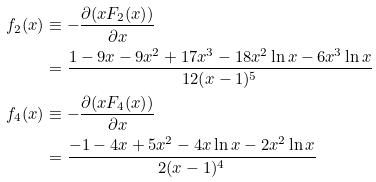Convert formula to latex. <formula><loc_0><loc_0><loc_500><loc_500>f _ { 2 } ( x ) & \equiv - \frac { \partial ( x F _ { 2 } ( x ) ) } { \partial x } \, \\ & = \frac { 1 - 9 x - 9 x ^ { 2 } + 1 7 x ^ { 3 } - 1 8 x ^ { 2 } \ln x - 6 x ^ { 3 } \ln x } { 1 2 ( x - 1 ) ^ { 5 } } \, \\ f _ { 4 } ( x ) & \equiv - \frac { \partial ( x F _ { 4 } ( x ) ) } { \partial x } \, \\ & = \frac { - 1 - 4 x + 5 x ^ { 2 } - 4 x \ln x - 2 x ^ { 2 } \ln x } { 2 ( x - 1 ) ^ { 4 } } \,</formula> 